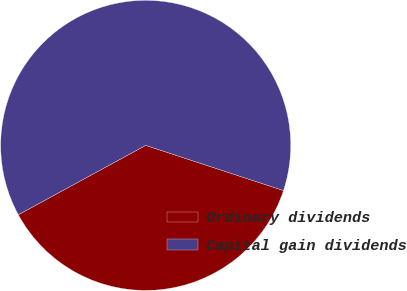Convert chart. <chart><loc_0><loc_0><loc_500><loc_500><pie_chart><fcel>Ordinary dividends<fcel>Capital gain dividends<nl><fcel>37.02%<fcel>62.98%<nl></chart> 